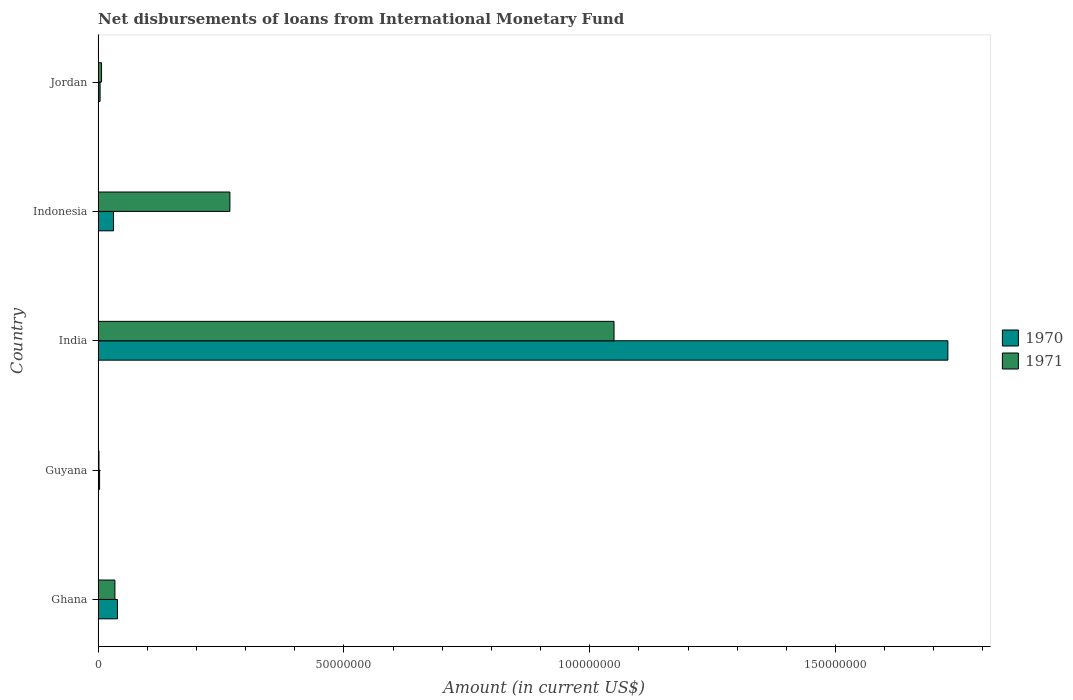How many different coloured bars are there?
Offer a very short reply. 2. Are the number of bars per tick equal to the number of legend labels?
Keep it short and to the point. Yes. Are the number of bars on each tick of the Y-axis equal?
Make the answer very short. Yes. How many bars are there on the 3rd tick from the bottom?
Provide a short and direct response. 2. What is the label of the 5th group of bars from the top?
Your answer should be compact. Ghana. In how many cases, is the number of bars for a given country not equal to the number of legend labels?
Give a very brief answer. 0. What is the amount of loans disbursed in 1970 in Indonesia?
Provide a succinct answer. 3.14e+06. Across all countries, what is the maximum amount of loans disbursed in 1971?
Your answer should be very brief. 1.05e+08. Across all countries, what is the minimum amount of loans disbursed in 1971?
Ensure brevity in your answer.  1.76e+05. In which country was the amount of loans disbursed in 1970 maximum?
Provide a succinct answer. India. In which country was the amount of loans disbursed in 1970 minimum?
Make the answer very short. Guyana. What is the total amount of loans disbursed in 1970 in the graph?
Offer a terse response. 1.81e+08. What is the difference between the amount of loans disbursed in 1970 in Ghana and that in Indonesia?
Provide a short and direct response. 7.99e+05. What is the difference between the amount of loans disbursed in 1971 in Guyana and the amount of loans disbursed in 1970 in Jordan?
Your response must be concise. -2.23e+05. What is the average amount of loans disbursed in 1970 per country?
Provide a short and direct response. 3.61e+07. What is the difference between the amount of loans disbursed in 1971 and amount of loans disbursed in 1970 in Indonesia?
Provide a succinct answer. 2.37e+07. What is the ratio of the amount of loans disbursed in 1970 in Guyana to that in Jordan?
Your answer should be compact. 0.75. Is the amount of loans disbursed in 1970 in India less than that in Indonesia?
Offer a terse response. No. Is the difference between the amount of loans disbursed in 1971 in Ghana and Jordan greater than the difference between the amount of loans disbursed in 1970 in Ghana and Jordan?
Offer a terse response. No. What is the difference between the highest and the second highest amount of loans disbursed in 1970?
Offer a very short reply. 1.69e+08. What is the difference between the highest and the lowest amount of loans disbursed in 1971?
Offer a very short reply. 1.05e+08. In how many countries, is the amount of loans disbursed in 1970 greater than the average amount of loans disbursed in 1970 taken over all countries?
Give a very brief answer. 1. Is the sum of the amount of loans disbursed in 1971 in Ghana and Jordan greater than the maximum amount of loans disbursed in 1970 across all countries?
Your response must be concise. No. Are all the bars in the graph horizontal?
Provide a short and direct response. Yes. How many countries are there in the graph?
Provide a succinct answer. 5. What is the difference between two consecutive major ticks on the X-axis?
Provide a short and direct response. 5.00e+07. How many legend labels are there?
Your answer should be very brief. 2. What is the title of the graph?
Provide a short and direct response. Net disbursements of loans from International Monetary Fund. What is the label or title of the X-axis?
Your response must be concise. Amount (in current US$). What is the Amount (in current US$) in 1970 in Ghana?
Keep it short and to the point. 3.94e+06. What is the Amount (in current US$) of 1971 in Ghana?
Your answer should be very brief. 3.42e+06. What is the Amount (in current US$) in 1970 in Guyana?
Keep it short and to the point. 2.99e+05. What is the Amount (in current US$) of 1971 in Guyana?
Keep it short and to the point. 1.76e+05. What is the Amount (in current US$) of 1970 in India?
Ensure brevity in your answer.  1.73e+08. What is the Amount (in current US$) in 1971 in India?
Give a very brief answer. 1.05e+08. What is the Amount (in current US$) in 1970 in Indonesia?
Offer a very short reply. 3.14e+06. What is the Amount (in current US$) in 1971 in Indonesia?
Keep it short and to the point. 2.68e+07. What is the Amount (in current US$) of 1970 in Jordan?
Your answer should be compact. 3.99e+05. What is the Amount (in current US$) in 1971 in Jordan?
Your answer should be compact. 6.99e+05. Across all countries, what is the maximum Amount (in current US$) in 1970?
Your answer should be very brief. 1.73e+08. Across all countries, what is the maximum Amount (in current US$) of 1971?
Provide a succinct answer. 1.05e+08. Across all countries, what is the minimum Amount (in current US$) of 1970?
Ensure brevity in your answer.  2.99e+05. Across all countries, what is the minimum Amount (in current US$) of 1971?
Give a very brief answer. 1.76e+05. What is the total Amount (in current US$) in 1970 in the graph?
Make the answer very short. 1.81e+08. What is the total Amount (in current US$) of 1971 in the graph?
Provide a succinct answer. 1.36e+08. What is the difference between the Amount (in current US$) of 1970 in Ghana and that in Guyana?
Ensure brevity in your answer.  3.64e+06. What is the difference between the Amount (in current US$) of 1971 in Ghana and that in Guyana?
Offer a very short reply. 3.24e+06. What is the difference between the Amount (in current US$) of 1970 in Ghana and that in India?
Give a very brief answer. -1.69e+08. What is the difference between the Amount (in current US$) of 1971 in Ghana and that in India?
Provide a succinct answer. -1.02e+08. What is the difference between the Amount (in current US$) of 1970 in Ghana and that in Indonesia?
Give a very brief answer. 7.99e+05. What is the difference between the Amount (in current US$) of 1971 in Ghana and that in Indonesia?
Offer a terse response. -2.34e+07. What is the difference between the Amount (in current US$) in 1970 in Ghana and that in Jordan?
Give a very brief answer. 3.54e+06. What is the difference between the Amount (in current US$) of 1971 in Ghana and that in Jordan?
Make the answer very short. 2.72e+06. What is the difference between the Amount (in current US$) of 1970 in Guyana and that in India?
Give a very brief answer. -1.73e+08. What is the difference between the Amount (in current US$) in 1971 in Guyana and that in India?
Your answer should be compact. -1.05e+08. What is the difference between the Amount (in current US$) of 1970 in Guyana and that in Indonesia?
Ensure brevity in your answer.  -2.84e+06. What is the difference between the Amount (in current US$) of 1971 in Guyana and that in Indonesia?
Keep it short and to the point. -2.66e+07. What is the difference between the Amount (in current US$) in 1970 in Guyana and that in Jordan?
Keep it short and to the point. -1.00e+05. What is the difference between the Amount (in current US$) in 1971 in Guyana and that in Jordan?
Your answer should be compact. -5.23e+05. What is the difference between the Amount (in current US$) in 1970 in India and that in Indonesia?
Your answer should be compact. 1.70e+08. What is the difference between the Amount (in current US$) of 1971 in India and that in Indonesia?
Provide a succinct answer. 7.81e+07. What is the difference between the Amount (in current US$) in 1970 in India and that in Jordan?
Your answer should be very brief. 1.72e+08. What is the difference between the Amount (in current US$) in 1971 in India and that in Jordan?
Ensure brevity in your answer.  1.04e+08. What is the difference between the Amount (in current US$) of 1970 in Indonesia and that in Jordan?
Provide a short and direct response. 2.74e+06. What is the difference between the Amount (in current US$) in 1971 in Indonesia and that in Jordan?
Make the answer very short. 2.61e+07. What is the difference between the Amount (in current US$) of 1970 in Ghana and the Amount (in current US$) of 1971 in Guyana?
Ensure brevity in your answer.  3.76e+06. What is the difference between the Amount (in current US$) in 1970 in Ghana and the Amount (in current US$) in 1971 in India?
Keep it short and to the point. -1.01e+08. What is the difference between the Amount (in current US$) in 1970 in Ghana and the Amount (in current US$) in 1971 in Indonesia?
Offer a very short reply. -2.29e+07. What is the difference between the Amount (in current US$) in 1970 in Ghana and the Amount (in current US$) in 1971 in Jordan?
Offer a very short reply. 3.24e+06. What is the difference between the Amount (in current US$) in 1970 in Guyana and the Amount (in current US$) in 1971 in India?
Ensure brevity in your answer.  -1.05e+08. What is the difference between the Amount (in current US$) in 1970 in Guyana and the Amount (in current US$) in 1971 in Indonesia?
Provide a succinct answer. -2.65e+07. What is the difference between the Amount (in current US$) of 1970 in Guyana and the Amount (in current US$) of 1971 in Jordan?
Ensure brevity in your answer.  -4.00e+05. What is the difference between the Amount (in current US$) of 1970 in India and the Amount (in current US$) of 1971 in Indonesia?
Provide a succinct answer. 1.46e+08. What is the difference between the Amount (in current US$) of 1970 in India and the Amount (in current US$) of 1971 in Jordan?
Ensure brevity in your answer.  1.72e+08. What is the difference between the Amount (in current US$) in 1970 in Indonesia and the Amount (in current US$) in 1971 in Jordan?
Give a very brief answer. 2.44e+06. What is the average Amount (in current US$) of 1970 per country?
Give a very brief answer. 3.61e+07. What is the average Amount (in current US$) in 1971 per country?
Offer a very short reply. 2.72e+07. What is the difference between the Amount (in current US$) of 1970 and Amount (in current US$) of 1971 in Ghana?
Make the answer very short. 5.20e+05. What is the difference between the Amount (in current US$) of 1970 and Amount (in current US$) of 1971 in Guyana?
Give a very brief answer. 1.23e+05. What is the difference between the Amount (in current US$) in 1970 and Amount (in current US$) in 1971 in India?
Your answer should be compact. 6.79e+07. What is the difference between the Amount (in current US$) of 1970 and Amount (in current US$) of 1971 in Indonesia?
Your answer should be compact. -2.37e+07. What is the ratio of the Amount (in current US$) in 1970 in Ghana to that in Guyana?
Offer a very short reply. 13.17. What is the ratio of the Amount (in current US$) in 1971 in Ghana to that in Guyana?
Ensure brevity in your answer.  19.42. What is the ratio of the Amount (in current US$) of 1970 in Ghana to that in India?
Provide a short and direct response. 0.02. What is the ratio of the Amount (in current US$) in 1971 in Ghana to that in India?
Your response must be concise. 0.03. What is the ratio of the Amount (in current US$) of 1970 in Ghana to that in Indonesia?
Keep it short and to the point. 1.25. What is the ratio of the Amount (in current US$) in 1971 in Ghana to that in Indonesia?
Your answer should be very brief. 0.13. What is the ratio of the Amount (in current US$) of 1970 in Ghana to that in Jordan?
Provide a succinct answer. 9.87. What is the ratio of the Amount (in current US$) in 1971 in Ghana to that in Jordan?
Keep it short and to the point. 4.89. What is the ratio of the Amount (in current US$) of 1970 in Guyana to that in India?
Provide a succinct answer. 0. What is the ratio of the Amount (in current US$) of 1971 in Guyana to that in India?
Your answer should be very brief. 0. What is the ratio of the Amount (in current US$) of 1970 in Guyana to that in Indonesia?
Offer a very short reply. 0.1. What is the ratio of the Amount (in current US$) in 1971 in Guyana to that in Indonesia?
Give a very brief answer. 0.01. What is the ratio of the Amount (in current US$) of 1970 in Guyana to that in Jordan?
Ensure brevity in your answer.  0.75. What is the ratio of the Amount (in current US$) of 1971 in Guyana to that in Jordan?
Give a very brief answer. 0.25. What is the ratio of the Amount (in current US$) of 1970 in India to that in Indonesia?
Your response must be concise. 55.07. What is the ratio of the Amount (in current US$) of 1971 in India to that in Indonesia?
Make the answer very short. 3.91. What is the ratio of the Amount (in current US$) of 1970 in India to that in Jordan?
Your answer should be very brief. 433.25. What is the ratio of the Amount (in current US$) in 1971 in India to that in Jordan?
Give a very brief answer. 150.14. What is the ratio of the Amount (in current US$) of 1970 in Indonesia to that in Jordan?
Give a very brief answer. 7.87. What is the ratio of the Amount (in current US$) in 1971 in Indonesia to that in Jordan?
Offer a very short reply. 38.35. What is the difference between the highest and the second highest Amount (in current US$) of 1970?
Ensure brevity in your answer.  1.69e+08. What is the difference between the highest and the second highest Amount (in current US$) in 1971?
Provide a succinct answer. 7.81e+07. What is the difference between the highest and the lowest Amount (in current US$) of 1970?
Provide a succinct answer. 1.73e+08. What is the difference between the highest and the lowest Amount (in current US$) in 1971?
Ensure brevity in your answer.  1.05e+08. 